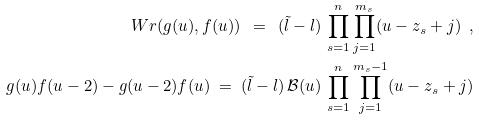Convert formula to latex. <formula><loc_0><loc_0><loc_500><loc_500>\ W r ( g ( u ) , f ( u ) ) \ = \ ( \tilde { l } - l ) \, \prod _ { s = 1 } ^ { n } \prod _ { j = 1 } ^ { m _ { s } } ( u - z _ { s } + j ) \ , \\ g ( u ) f ( u - 2 ) - g ( u - 2 ) f ( u ) \ = \ ( \tilde { l } - l ) \, \mathcal { B } ( u ) \, \prod _ { s = 1 } ^ { n } \prod _ { j = 1 } ^ { m _ { s } - 1 } ( u - z _ { s } + j )</formula> 